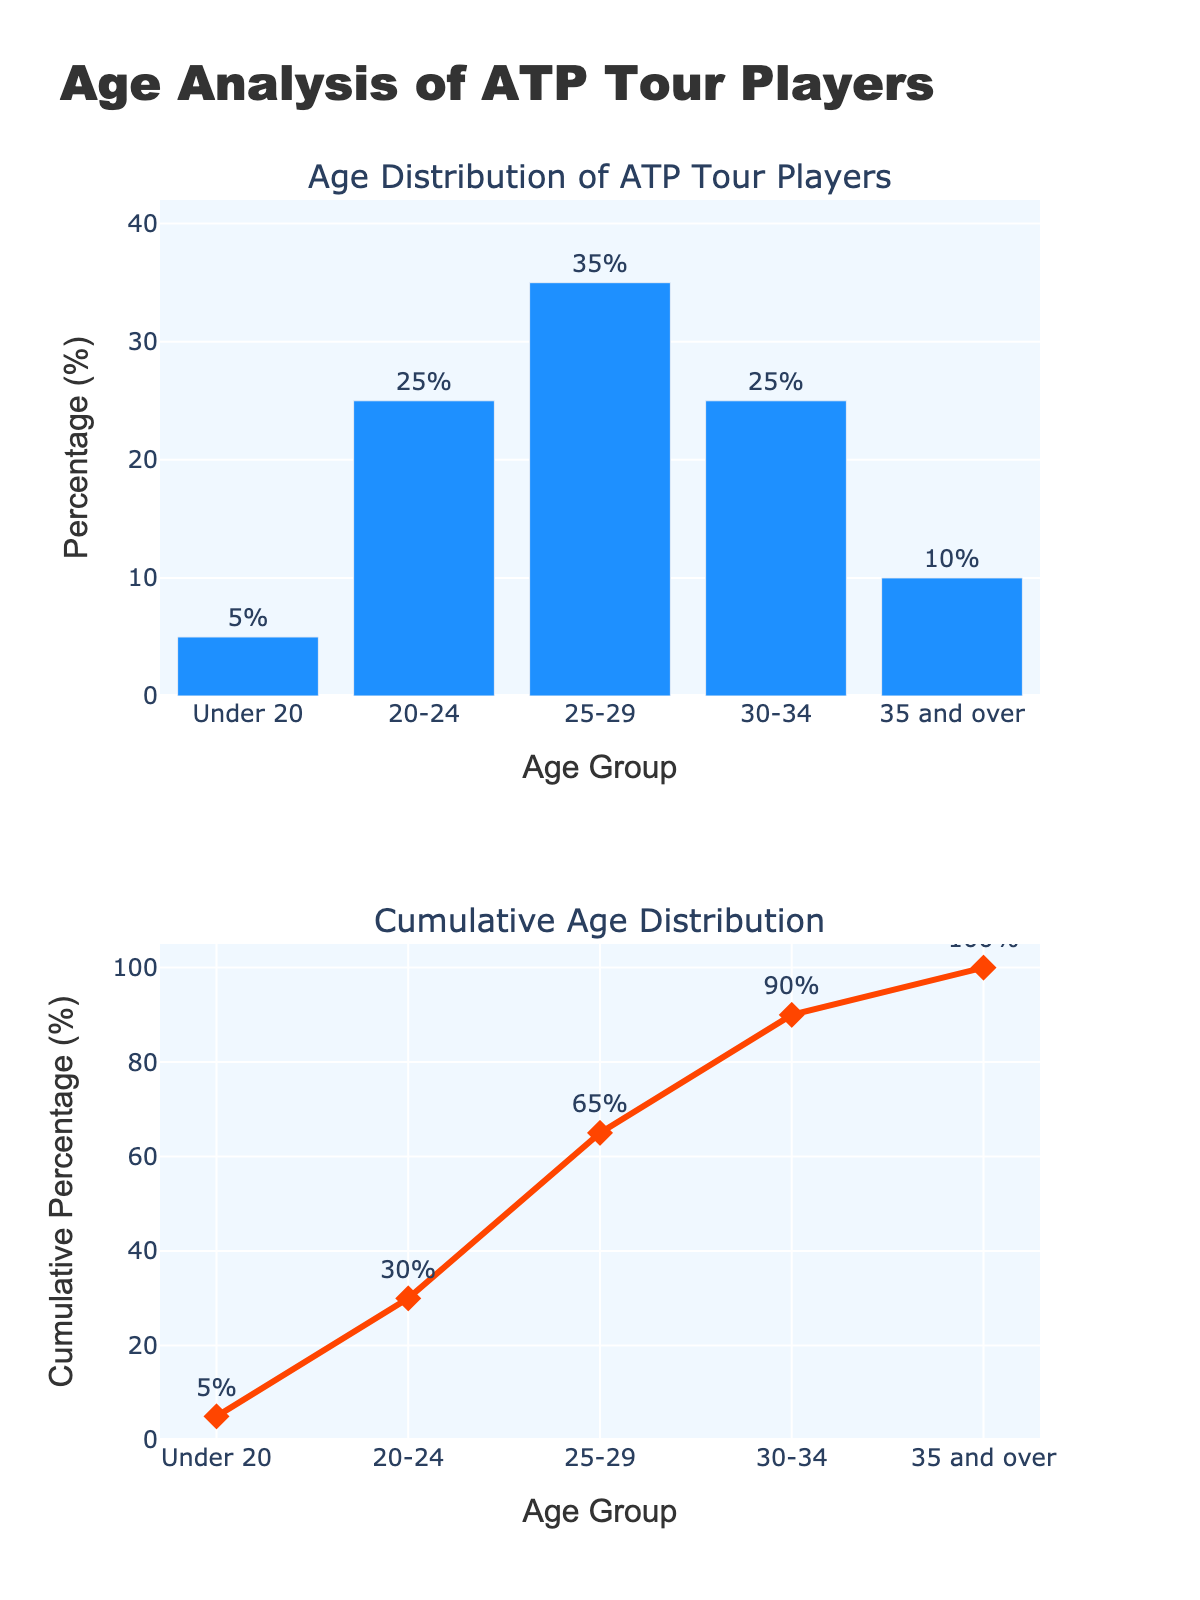What is the title of the first subplot? The first subplot's title is stated above the bar chart in the figure. It reads "Age Distribution of ATP Tour Players."
Answer: Age Distribution of ATP Tour Players What color are the bars in the first subplot? The color of the bars can be identified visually. All bars in the bar chart are in a single color, which is blue.
Answer: Blue What is the percentage of players in the 25-29 age group? Look at the bar corresponding to the 25-29 age group in the bar chart. The bar reaches up to the labeled percentage of 35%.
Answer: 35% Which age group has the highest percentage of players? Compare the heights of the bars in the bar chart. The tallest bar corresponds to the 25-29 age group, showing the highest percentage.
Answer: 25-29 What is the cumulative percentage of players aged 30-34? To find this, look at the cumulative distribution in the second subplot. The point corresponding to the 30-34 age group is labeled with its cumulative percentage, which is 90%.
Answer: 90% How many age groups are displayed in the figure? Count the distinct bars or points along the x-axis in the bar chart or line chart. There are five distinct age groups.
Answer: 5 What percentage of players are aged 35 and over, and how does it compare to the percentage of players aged 20-24? Look at the bars for the 35 and over and 20-24 age groups in the bar chart. The percentage for 35 and over is 10%, and for 20-24, it is 25%. The 20-24 age group has a higher percentage.
Answer: 10%, lower What is the cumulative percentage for players aged under 20? In the line chart of the second subplot, find the cumulative percentage corresponding to the "Under 20" age group, which is 5%.
Answer: 5% By how much does the percentage of players in the 25-29 age group exceed the percentage of players in the 20-24 age group? Subtract the percentage of the 20-24 age group (25%) from that of the 25-29 age group (35%). The difference is 35% - 25% = 10%.
Answer: 10% What is the cumulative percentage difference between the age groups of 20-24 and 25-29? According to the cumulative distribution, the cumulative percentage for 20-24 is 30% and for 25-29 is 65%. The difference is 65% - 30% = 35%.
Answer: 35% 